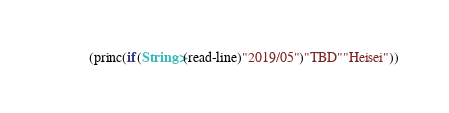Convert code to text. <code><loc_0><loc_0><loc_500><loc_500><_Lisp_>(princ(if(String>(read-line)"2019/05")"TBD""Heisei"))</code> 